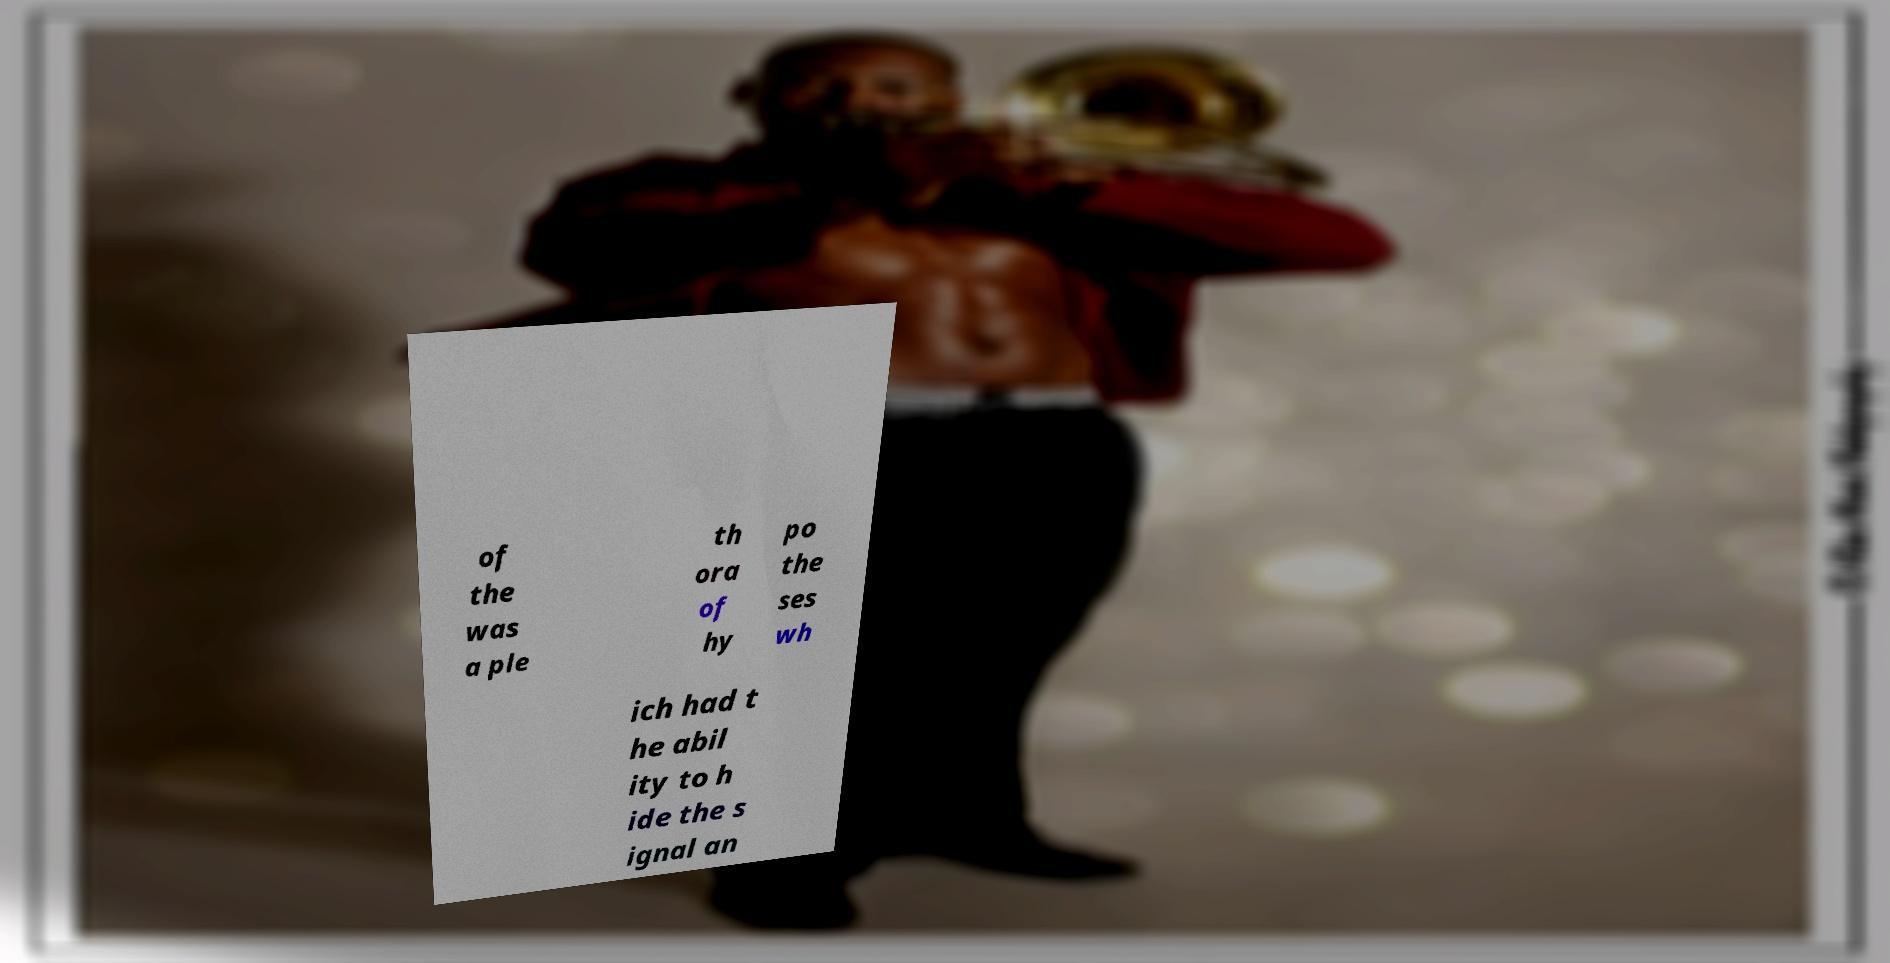I need the written content from this picture converted into text. Can you do that? of the was a ple th ora of hy po the ses wh ich had t he abil ity to h ide the s ignal an 